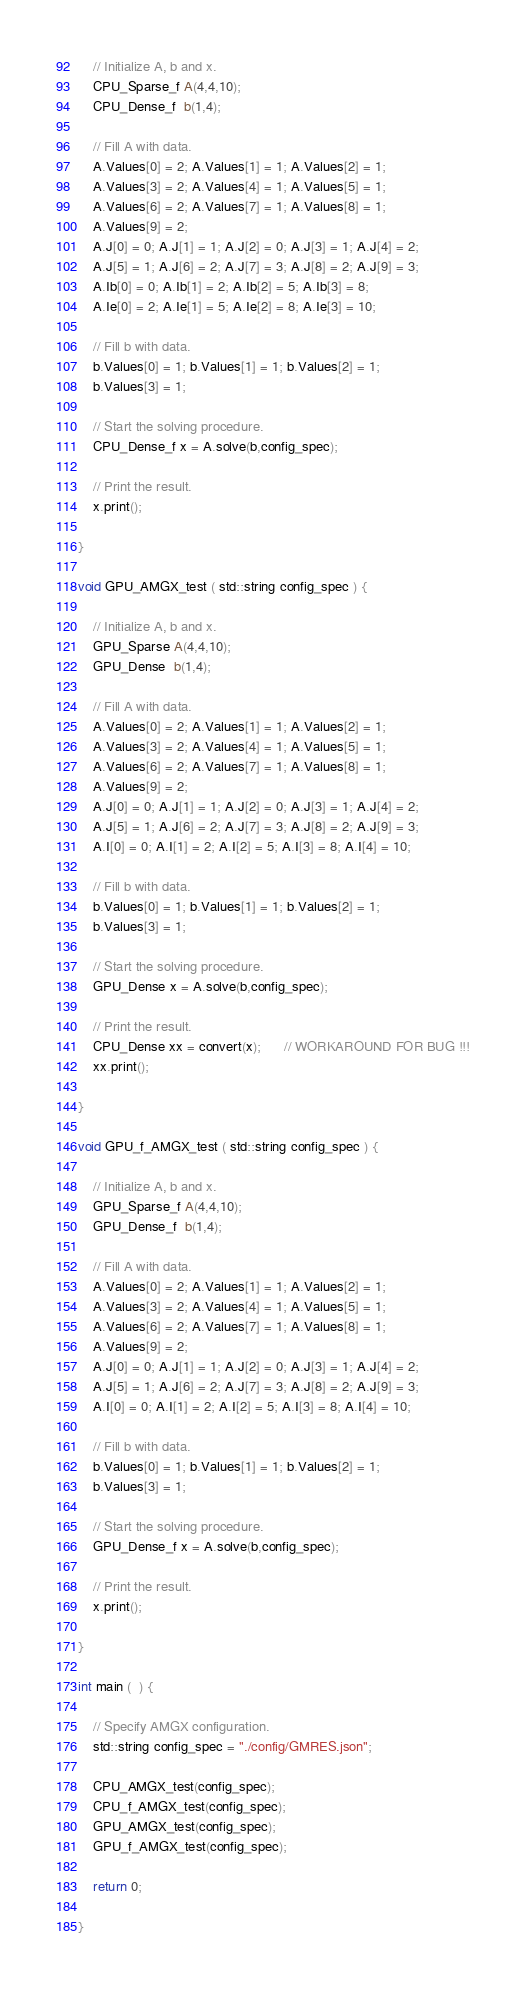<code> <loc_0><loc_0><loc_500><loc_500><_Cuda_>
    // Initialize A, b and x.
    CPU_Sparse_f A(4,4,10);
    CPU_Dense_f  b(1,4);
   
    // Fill A with data.
    A.Values[0] = 2; A.Values[1] = 1; A.Values[2] = 1;
    A.Values[3] = 2; A.Values[4] = 1; A.Values[5] = 1;
    A.Values[6] = 2; A.Values[7] = 1; A.Values[8] = 1;
    A.Values[9] = 2;
    A.J[0] = 0; A.J[1] = 1; A.J[2] = 0; A.J[3] = 1; A.J[4] = 2;
    A.J[5] = 1; A.J[6] = 2; A.J[7] = 3; A.J[8] = 2; A.J[9] = 3;
    A.Ib[0] = 0; A.Ib[1] = 2; A.Ib[2] = 5; A.Ib[3] = 8;
    A.Ie[0] = 2; A.Ie[1] = 5; A.Ie[2] = 8; A.Ie[3] = 10;
    
    // Fill b with data.
    b.Values[0] = 1; b.Values[1] = 1; b.Values[2] = 1;
    b.Values[3] = 1;

    // Start the solving procedure.
    CPU_Dense_f x = A.solve(b,config_spec);

    // Print the result.    
    x.print();

}

void GPU_AMGX_test ( std::string config_spec ) {

    // Initialize A, b and x.
    GPU_Sparse A(4,4,10);
    GPU_Dense  b(1,4);
    
    // Fill A with data.
    A.Values[0] = 2; A.Values[1] = 1; A.Values[2] = 1;
    A.Values[3] = 2; A.Values[4] = 1; A.Values[5] = 1;
    A.Values[6] = 2; A.Values[7] = 1; A.Values[8] = 1;
    A.Values[9] = 2;
    A.J[0] = 0; A.J[1] = 1; A.J[2] = 0; A.J[3] = 1; A.J[4] = 2;
    A.J[5] = 1; A.J[6] = 2; A.J[7] = 3; A.J[8] = 2; A.J[9] = 3;
    A.I[0] = 0; A.I[1] = 2; A.I[2] = 5; A.I[3] = 8; A.I[4] = 10;
    
    // Fill b with data.
    b.Values[0] = 1; b.Values[1] = 1; b.Values[2] = 1;
    b.Values[3] = 1;

    // Start the solving procedure.
    GPU_Dense x = A.solve(b,config_spec);

    // Print the result.
    CPU_Dense xx = convert(x);      // WORKAROUND FOR BUG !!!
    xx.print();    

}

void GPU_f_AMGX_test ( std::string config_spec ) {

    // Initialize A, b and x.
    GPU_Sparse_f A(4,4,10);
    GPU_Dense_f  b(1,4);
    
    // Fill A with data.
    A.Values[0] = 2; A.Values[1] = 1; A.Values[2] = 1;
    A.Values[3] = 2; A.Values[4] = 1; A.Values[5] = 1;
    A.Values[6] = 2; A.Values[7] = 1; A.Values[8] = 1;
    A.Values[9] = 2;
    A.J[0] = 0; A.J[1] = 1; A.J[2] = 0; A.J[3] = 1; A.J[4] = 2;
    A.J[5] = 1; A.J[6] = 2; A.J[7] = 3; A.J[8] = 2; A.J[9] = 3;
    A.I[0] = 0; A.I[1] = 2; A.I[2] = 5; A.I[3] = 8; A.I[4] = 10;
    
    // Fill b with data.
    b.Values[0] = 1; b.Values[1] = 1; b.Values[2] = 1;
    b.Values[3] = 1;

    // Start the solving procedure.
    GPU_Dense_f x = A.solve(b,config_spec);

    // Print the result.    
    x.print();

}

int main (  ) {

    // Specify AMGX configuration.
    std::string config_spec = "./config/GMRES.json";

    CPU_AMGX_test(config_spec);
    CPU_f_AMGX_test(config_spec);
    GPU_AMGX_test(config_spec);
    GPU_f_AMGX_test(config_spec);

    return 0;

}</code> 